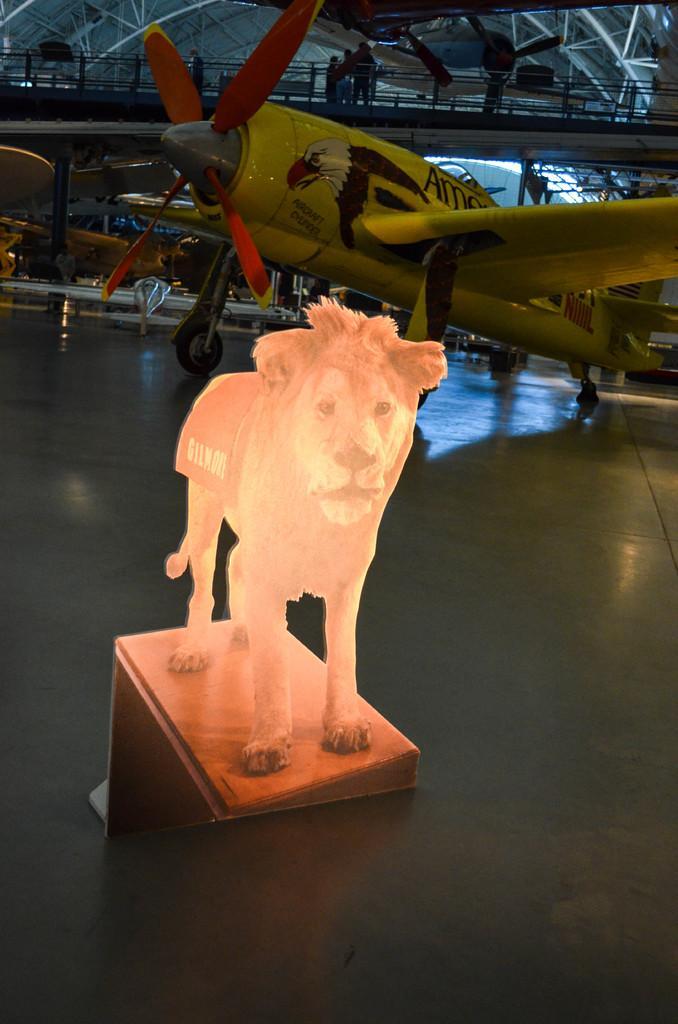How would you summarize this image in a sentence or two? Here I can see an idol of a lion which is placed on a table. At the bottom, I can see the floor. In the background there is an aircraft on the floor. At the top of the image there is a railing. Behind the railing few people are standing and there are many metal rods. 